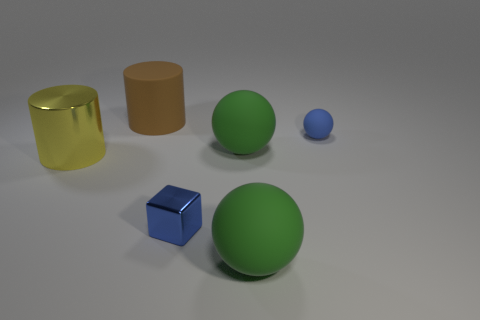There is another thing that is the same shape as the yellow metallic thing; what is it made of?
Your answer should be very brief. Rubber. Is there a big sphere that has the same material as the brown cylinder?
Give a very brief answer. Yes. Is the material of the small cube the same as the large yellow object?
Provide a short and direct response. Yes. What number of purple objects are large matte spheres or shiny spheres?
Provide a short and direct response. 0. Are there more green rubber balls that are to the left of the large brown cylinder than big matte cylinders?
Provide a short and direct response. No. Are there any matte objects that have the same color as the metallic cylinder?
Your answer should be very brief. No. What size is the metallic block?
Provide a succinct answer. Small. Is the color of the tiny matte ball the same as the small cube?
Provide a succinct answer. Yes. What number of things are matte cylinders or big green balls that are in front of the blue cube?
Ensure brevity in your answer.  2. How many green matte balls are to the left of the green matte object that is in front of the cylinder on the left side of the brown rubber thing?
Offer a terse response. 1. 